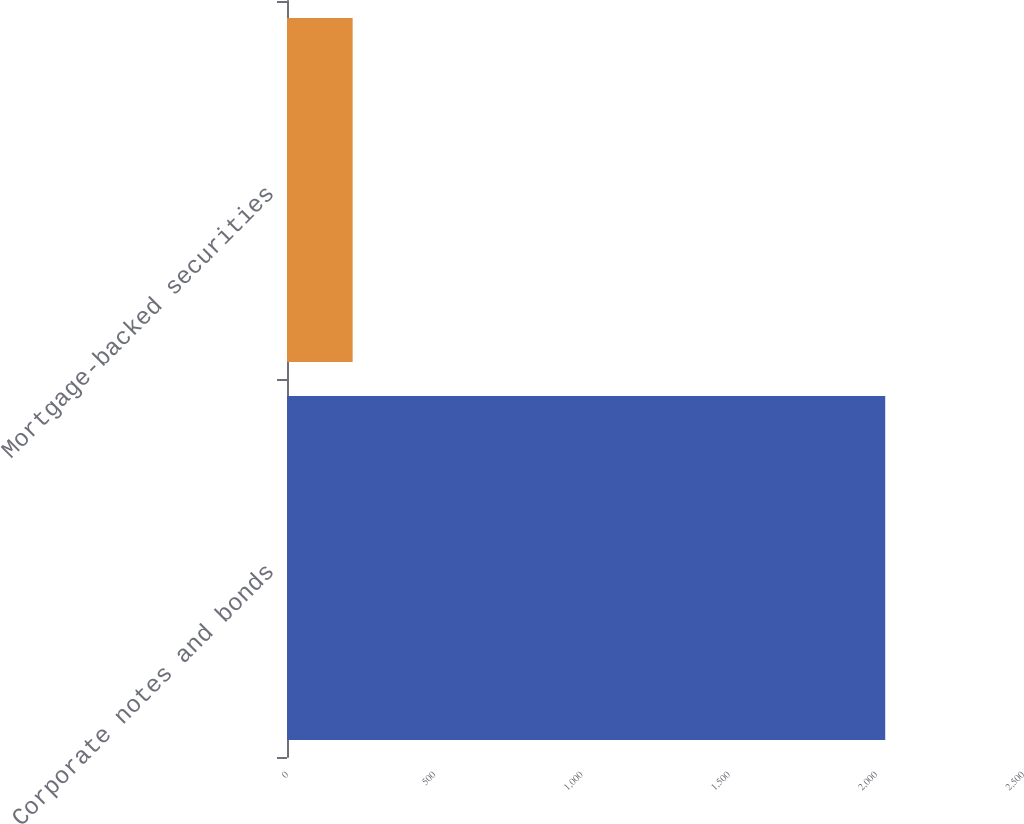Convert chart. <chart><loc_0><loc_0><loc_500><loc_500><bar_chart><fcel>Corporate notes and bonds<fcel>Mortgage-backed securities<nl><fcel>2032<fcel>223<nl></chart> 